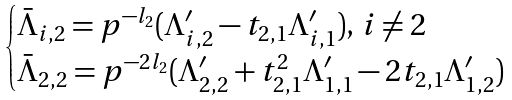Convert formula to latex. <formula><loc_0><loc_0><loc_500><loc_500>\begin{cases} \bar { \Lambda } _ { i , 2 } = p ^ { - l _ { 2 } } ( \Lambda _ { i , 2 } ^ { \prime } - t _ { 2 , 1 } \Lambda _ { i , 1 } ^ { \prime } ) , \, i \not = 2 & \\ \bar { \Lambda } _ { 2 , 2 } = p ^ { - 2 l _ { 2 } } ( \Lambda _ { 2 , 2 } ^ { \prime } + t _ { 2 , 1 } ^ { 2 } \Lambda _ { 1 , 1 } ^ { \prime } - 2 t _ { 2 , 1 } \Lambda _ { 1 , 2 } ^ { \prime } ) \end{cases}</formula> 